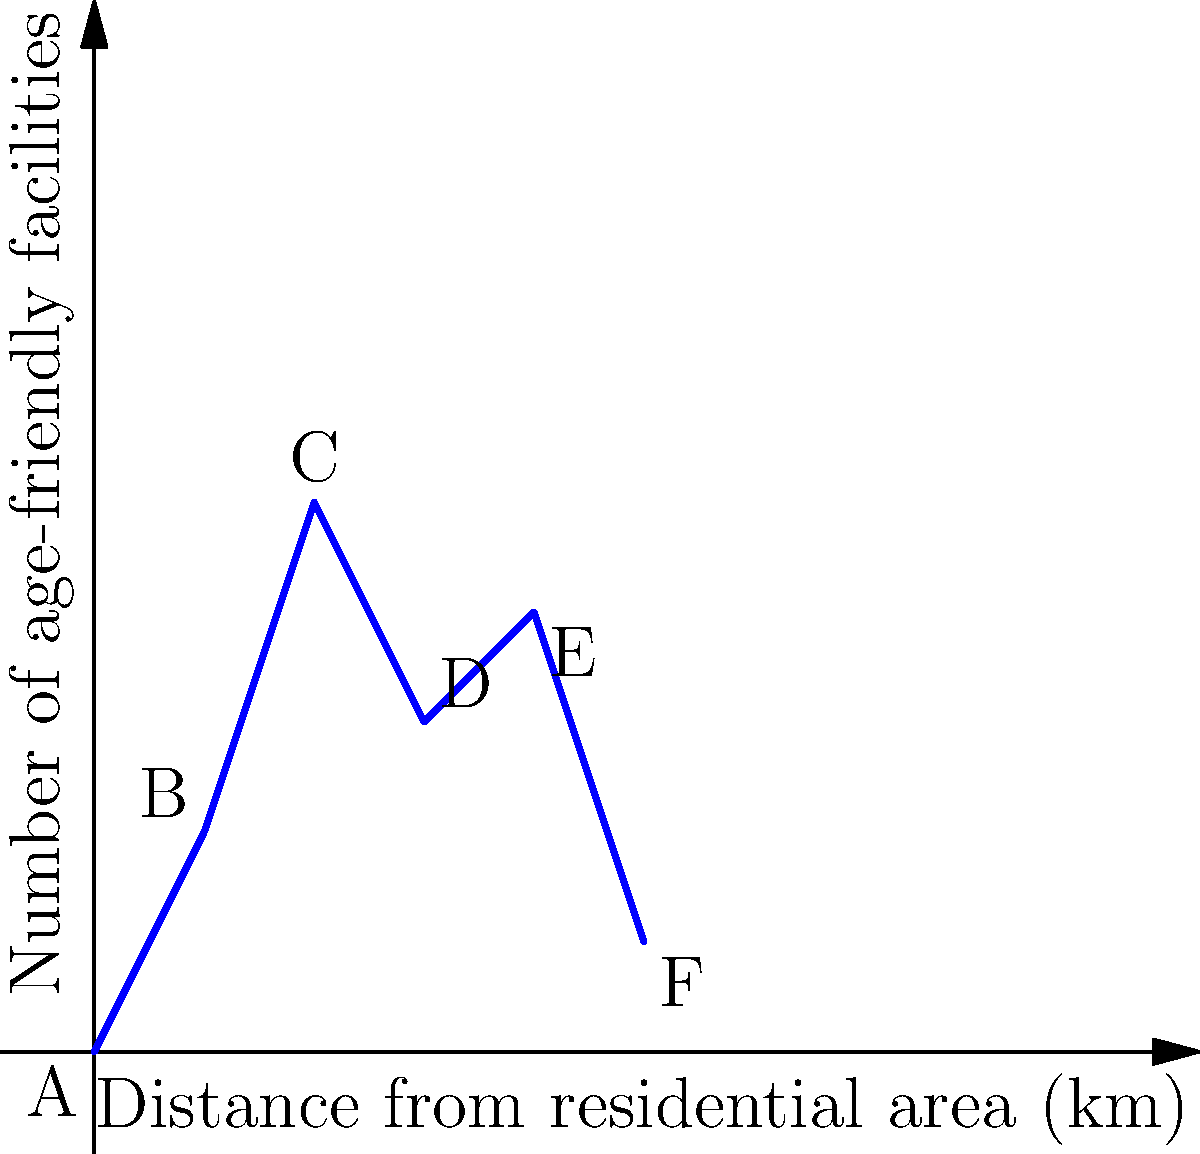The graph shows the distribution of age-friendly facilities within walking distance of your residential area. Which point on the graph represents the optimal location for new age-friendly facilities, considering both proximity and the number of existing facilities? To determine the optimal location for new age-friendly facilities, we need to consider both the distance from the residential area and the number of existing facilities. Let's analyze each point:

1. Point A (0,0): Closest to the residential area but no existing facilities.
2. Point B (1,2): Very close with 2 facilities.
3. Point C (2,5): Relatively close with the highest number of facilities (5).
4. Point D (3,3): Moderate distance with 3 facilities.
5. Point E (4,4): Further away with 4 facilities.
6. Point F (5,1): Farthest with only 1 facility.

The optimal location should balance proximity and the number of existing facilities. Point C stands out because:

1. It's within a reasonable walking distance (2 km).
2. It has the highest number of existing facilities (5).

Adding new facilities here would create a concentrated area of age-friendly services, making it easier for elderly residents to access multiple services in one trip.
Answer: C 